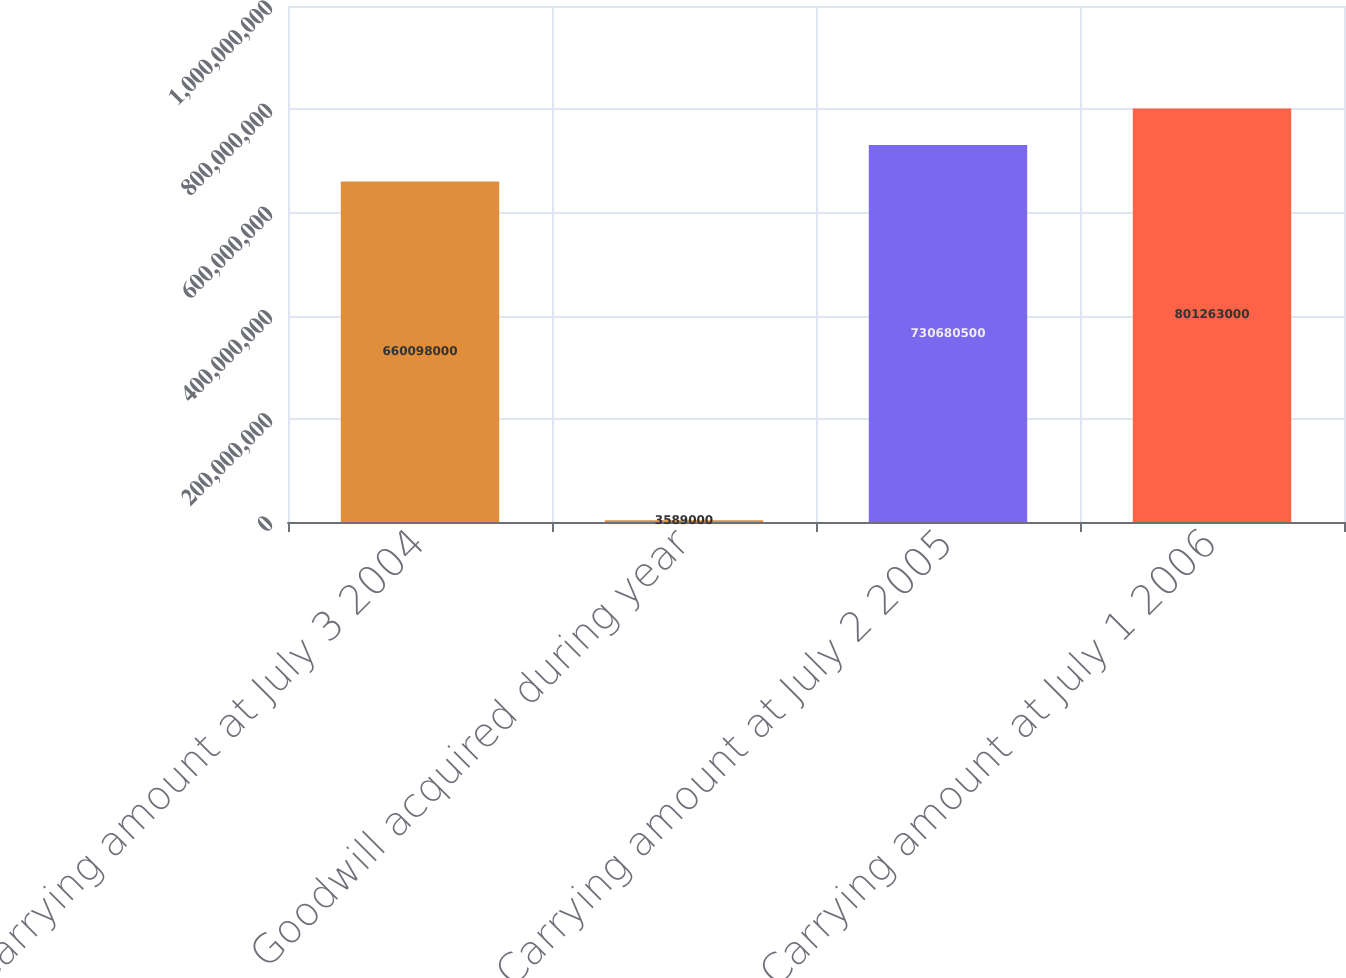<chart> <loc_0><loc_0><loc_500><loc_500><bar_chart><fcel>Carrying amount at July 3 2004<fcel>Goodwill acquired during year<fcel>Carrying amount at July 2 2005<fcel>Carrying amount at July 1 2006<nl><fcel>6.60098e+08<fcel>3.589e+06<fcel>7.3068e+08<fcel>8.01263e+08<nl></chart> 